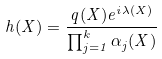Convert formula to latex. <formula><loc_0><loc_0><loc_500><loc_500>h ( X ) = \frac { q ( X ) e ^ { i \lambda ( X ) } } { \prod _ { j = 1 } ^ { k } \alpha _ { j } ( X ) }</formula> 